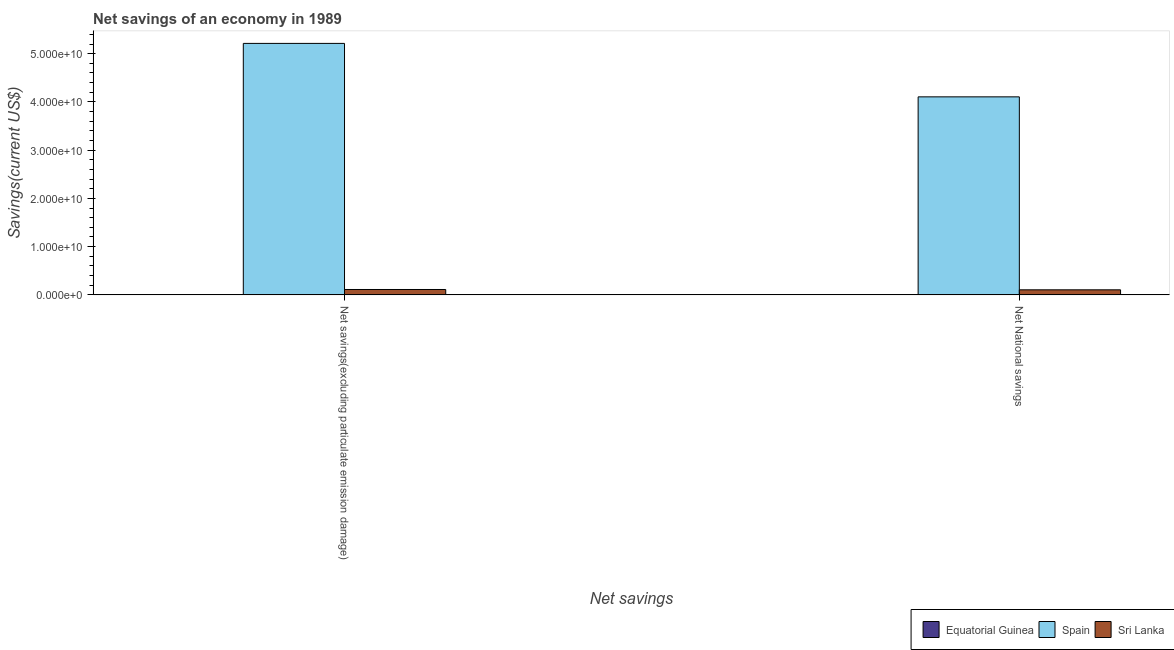Are the number of bars on each tick of the X-axis equal?
Provide a short and direct response. Yes. How many bars are there on the 1st tick from the left?
Offer a very short reply. 2. What is the label of the 1st group of bars from the left?
Offer a terse response. Net savings(excluding particulate emission damage). What is the net savings(excluding particulate emission damage) in Spain?
Offer a very short reply. 5.21e+1. Across all countries, what is the maximum net national savings?
Your answer should be compact. 4.10e+1. Across all countries, what is the minimum net savings(excluding particulate emission damage)?
Keep it short and to the point. 0. In which country was the net savings(excluding particulate emission damage) maximum?
Give a very brief answer. Spain. What is the total net savings(excluding particulate emission damage) in the graph?
Ensure brevity in your answer.  5.32e+1. What is the difference between the net national savings in Spain and that in Sri Lanka?
Give a very brief answer. 4.00e+1. What is the difference between the net national savings in Equatorial Guinea and the net savings(excluding particulate emission damage) in Spain?
Your response must be concise. -5.21e+1. What is the average net national savings per country?
Make the answer very short. 1.40e+1. What is the difference between the net savings(excluding particulate emission damage) and net national savings in Spain?
Ensure brevity in your answer.  1.11e+1. In how many countries, is the net national savings greater than 14000000000 US$?
Provide a succinct answer. 1. What is the ratio of the net national savings in Spain to that in Sri Lanka?
Give a very brief answer. 39.06. Is the net savings(excluding particulate emission damage) in Sri Lanka less than that in Spain?
Make the answer very short. Yes. In how many countries, is the net national savings greater than the average net national savings taken over all countries?
Keep it short and to the point. 1. Are all the bars in the graph horizontal?
Ensure brevity in your answer.  No. How many countries are there in the graph?
Offer a very short reply. 3. What is the difference between two consecutive major ticks on the Y-axis?
Ensure brevity in your answer.  1.00e+1. Does the graph contain any zero values?
Provide a succinct answer. Yes. Does the graph contain grids?
Your response must be concise. No. What is the title of the graph?
Your response must be concise. Net savings of an economy in 1989. Does "Guam" appear as one of the legend labels in the graph?
Offer a very short reply. No. What is the label or title of the X-axis?
Offer a very short reply. Net savings. What is the label or title of the Y-axis?
Provide a short and direct response. Savings(current US$). What is the Savings(current US$) of Spain in Net savings(excluding particulate emission damage)?
Ensure brevity in your answer.  5.21e+1. What is the Savings(current US$) in Sri Lanka in Net savings(excluding particulate emission damage)?
Make the answer very short. 1.12e+09. What is the Savings(current US$) in Spain in Net National savings?
Make the answer very short. 4.10e+1. What is the Savings(current US$) of Sri Lanka in Net National savings?
Your answer should be compact. 1.05e+09. Across all Net savings, what is the maximum Savings(current US$) in Spain?
Keep it short and to the point. 5.21e+1. Across all Net savings, what is the maximum Savings(current US$) of Sri Lanka?
Your answer should be compact. 1.12e+09. Across all Net savings, what is the minimum Savings(current US$) of Spain?
Offer a terse response. 4.10e+1. Across all Net savings, what is the minimum Savings(current US$) of Sri Lanka?
Your answer should be very brief. 1.05e+09. What is the total Savings(current US$) of Spain in the graph?
Provide a succinct answer. 9.32e+1. What is the total Savings(current US$) of Sri Lanka in the graph?
Offer a very short reply. 2.17e+09. What is the difference between the Savings(current US$) of Spain in Net savings(excluding particulate emission damage) and that in Net National savings?
Offer a terse response. 1.11e+1. What is the difference between the Savings(current US$) in Sri Lanka in Net savings(excluding particulate emission damage) and that in Net National savings?
Give a very brief answer. 6.88e+07. What is the difference between the Savings(current US$) of Spain in Net savings(excluding particulate emission damage) and the Savings(current US$) of Sri Lanka in Net National savings?
Provide a succinct answer. 5.11e+1. What is the average Savings(current US$) of Equatorial Guinea per Net savings?
Your response must be concise. 0. What is the average Savings(current US$) of Spain per Net savings?
Give a very brief answer. 4.66e+1. What is the average Savings(current US$) of Sri Lanka per Net savings?
Provide a short and direct response. 1.09e+09. What is the difference between the Savings(current US$) of Spain and Savings(current US$) of Sri Lanka in Net savings(excluding particulate emission damage)?
Your response must be concise. 5.10e+1. What is the difference between the Savings(current US$) in Spain and Savings(current US$) in Sri Lanka in Net National savings?
Provide a succinct answer. 4.00e+1. What is the ratio of the Savings(current US$) of Spain in Net savings(excluding particulate emission damage) to that in Net National savings?
Provide a short and direct response. 1.27. What is the ratio of the Savings(current US$) of Sri Lanka in Net savings(excluding particulate emission damage) to that in Net National savings?
Your answer should be compact. 1.07. What is the difference between the highest and the second highest Savings(current US$) of Spain?
Provide a short and direct response. 1.11e+1. What is the difference between the highest and the second highest Savings(current US$) of Sri Lanka?
Make the answer very short. 6.88e+07. What is the difference between the highest and the lowest Savings(current US$) of Spain?
Your answer should be compact. 1.11e+1. What is the difference between the highest and the lowest Savings(current US$) in Sri Lanka?
Your response must be concise. 6.88e+07. 